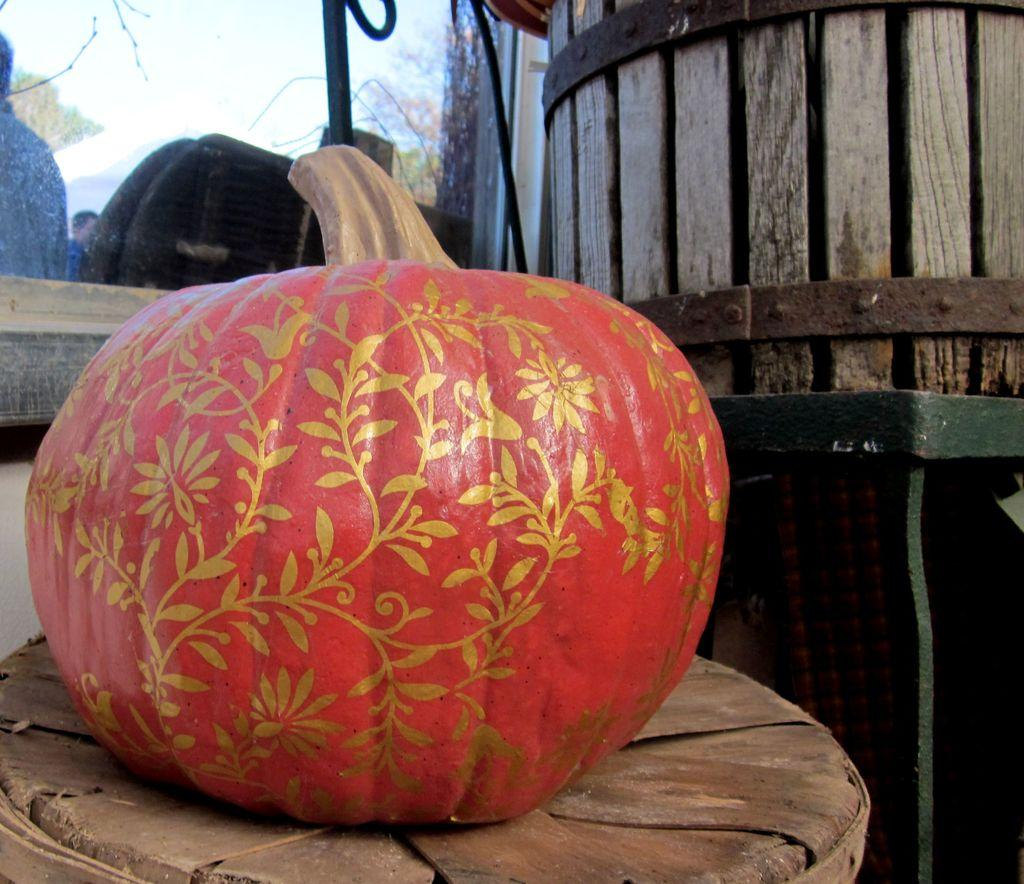What is on the table in the image? There is a pumpkin on the table. What is located beside the table? There is a barrel beside the table. What type of objects are near the table? Metal rods are present near the table. What can be seen in the background of the image? There are chairs, trees, and a group of people in the background of the image. What type of nose does the person in the image have? There is no person present in the image, so it is not possible to determine the type of nose they might have. 